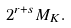<formula> <loc_0><loc_0><loc_500><loc_500>2 ^ { r + s } M _ { K } .</formula> 